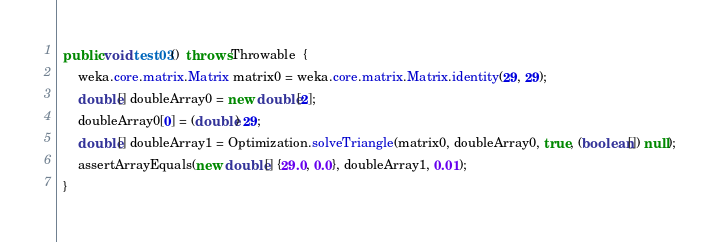Convert code to text. <code><loc_0><loc_0><loc_500><loc_500><_Java_>  public void test03()  throws Throwable  {
      weka.core.matrix.Matrix matrix0 = weka.core.matrix.Matrix.identity(29, 29);
      double[] doubleArray0 = new double[2];
      doubleArray0[0] = (double) 29;
      double[] doubleArray1 = Optimization.solveTriangle(matrix0, doubleArray0, true, (boolean[]) null);
      assertArrayEquals(new double[] {29.0, 0.0}, doubleArray1, 0.01);
  }
</code> 